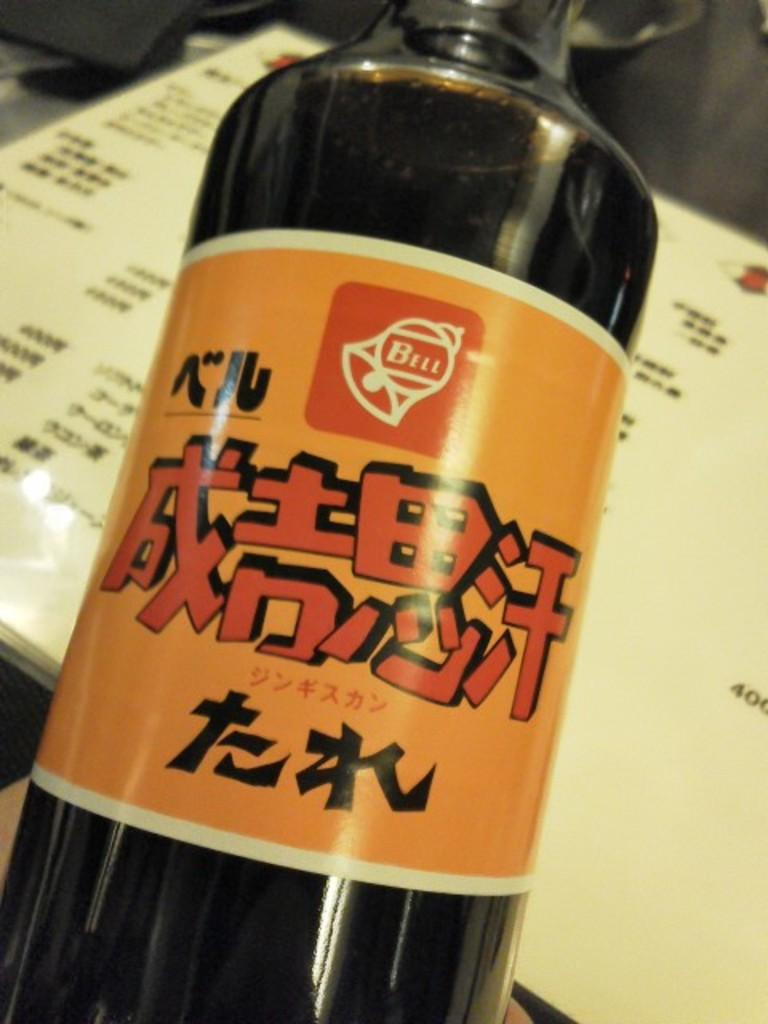<image>
Present a compact description of the photo's key features. bottle with orange label and asian writing with a bell logo and word bell in it 